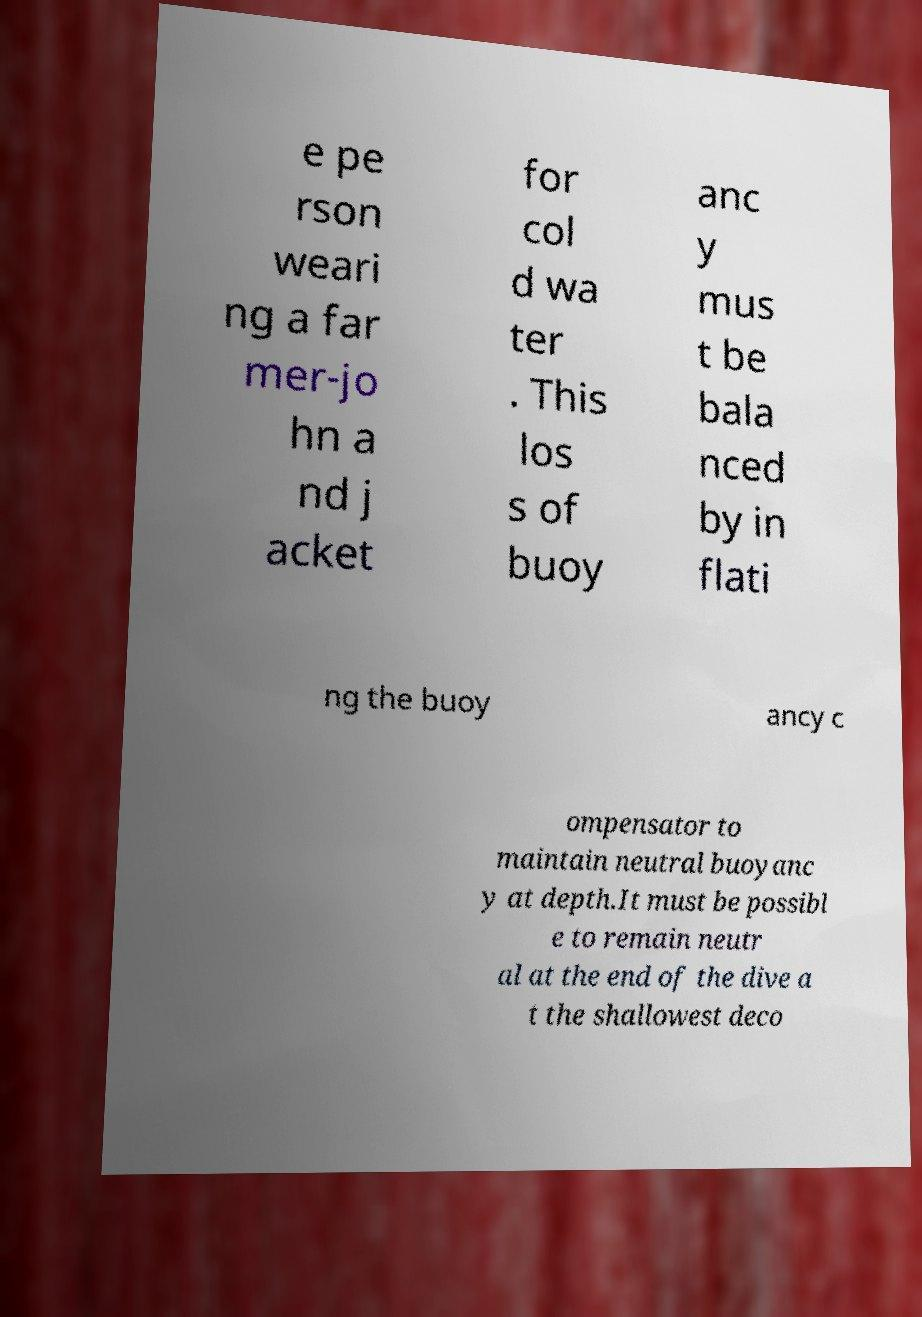Could you assist in decoding the text presented in this image and type it out clearly? e pe rson weari ng a far mer-jo hn a nd j acket for col d wa ter . This los s of buoy anc y mus t be bala nced by in flati ng the buoy ancy c ompensator to maintain neutral buoyanc y at depth.It must be possibl e to remain neutr al at the end of the dive a t the shallowest deco 